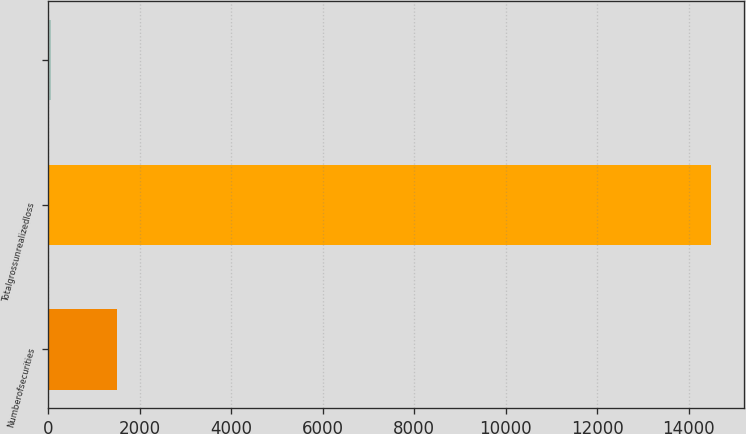Convert chart to OTSL. <chart><loc_0><loc_0><loc_500><loc_500><bar_chart><fcel>Numberofsecurities<fcel>Totalgrossunrealizedloss<fcel>Unnamed: 2<nl><fcel>1493.5<fcel>14485<fcel>50<nl></chart> 